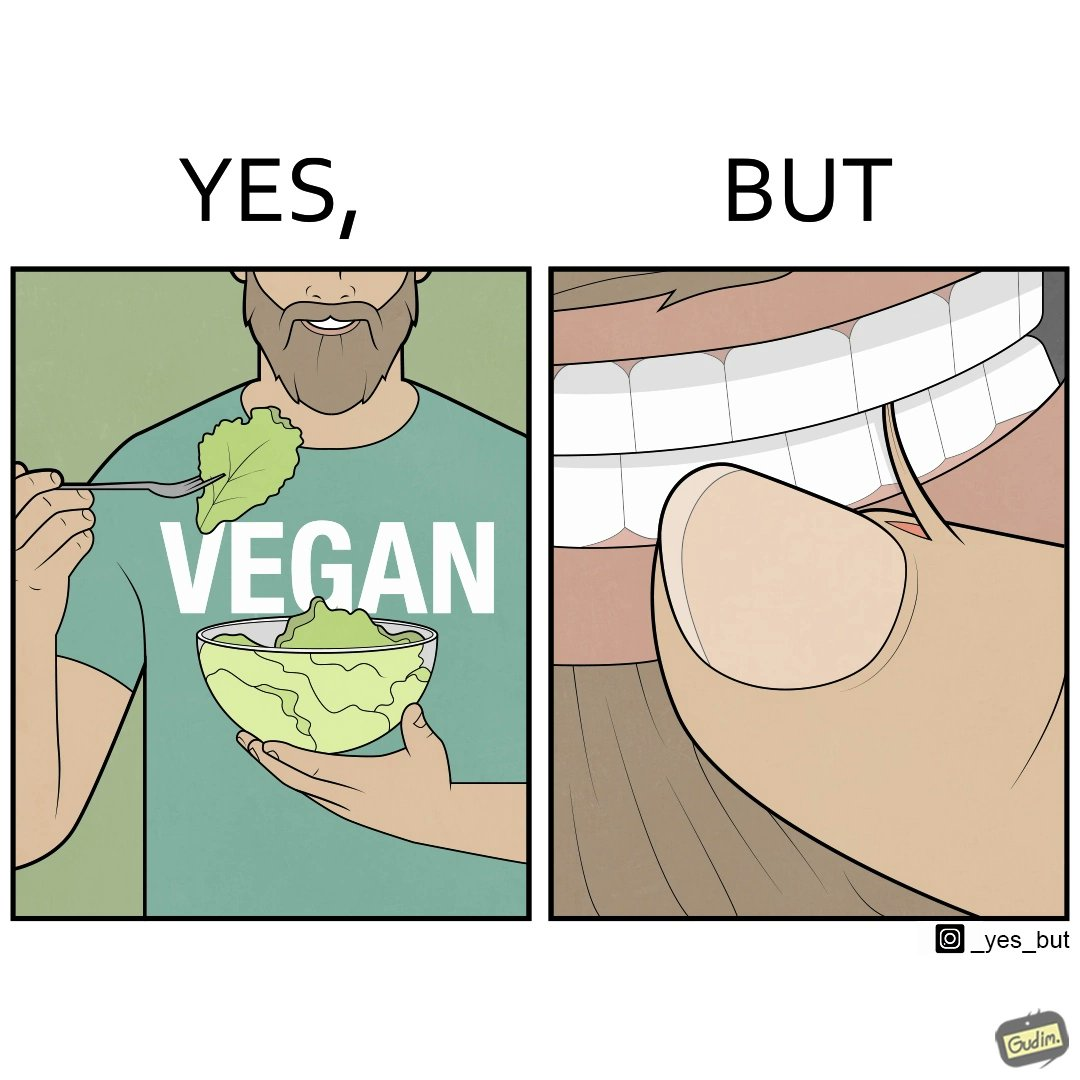What does this image depict? The image is funny because while the man claims to be vegan, he is biting skin off his own hand. 